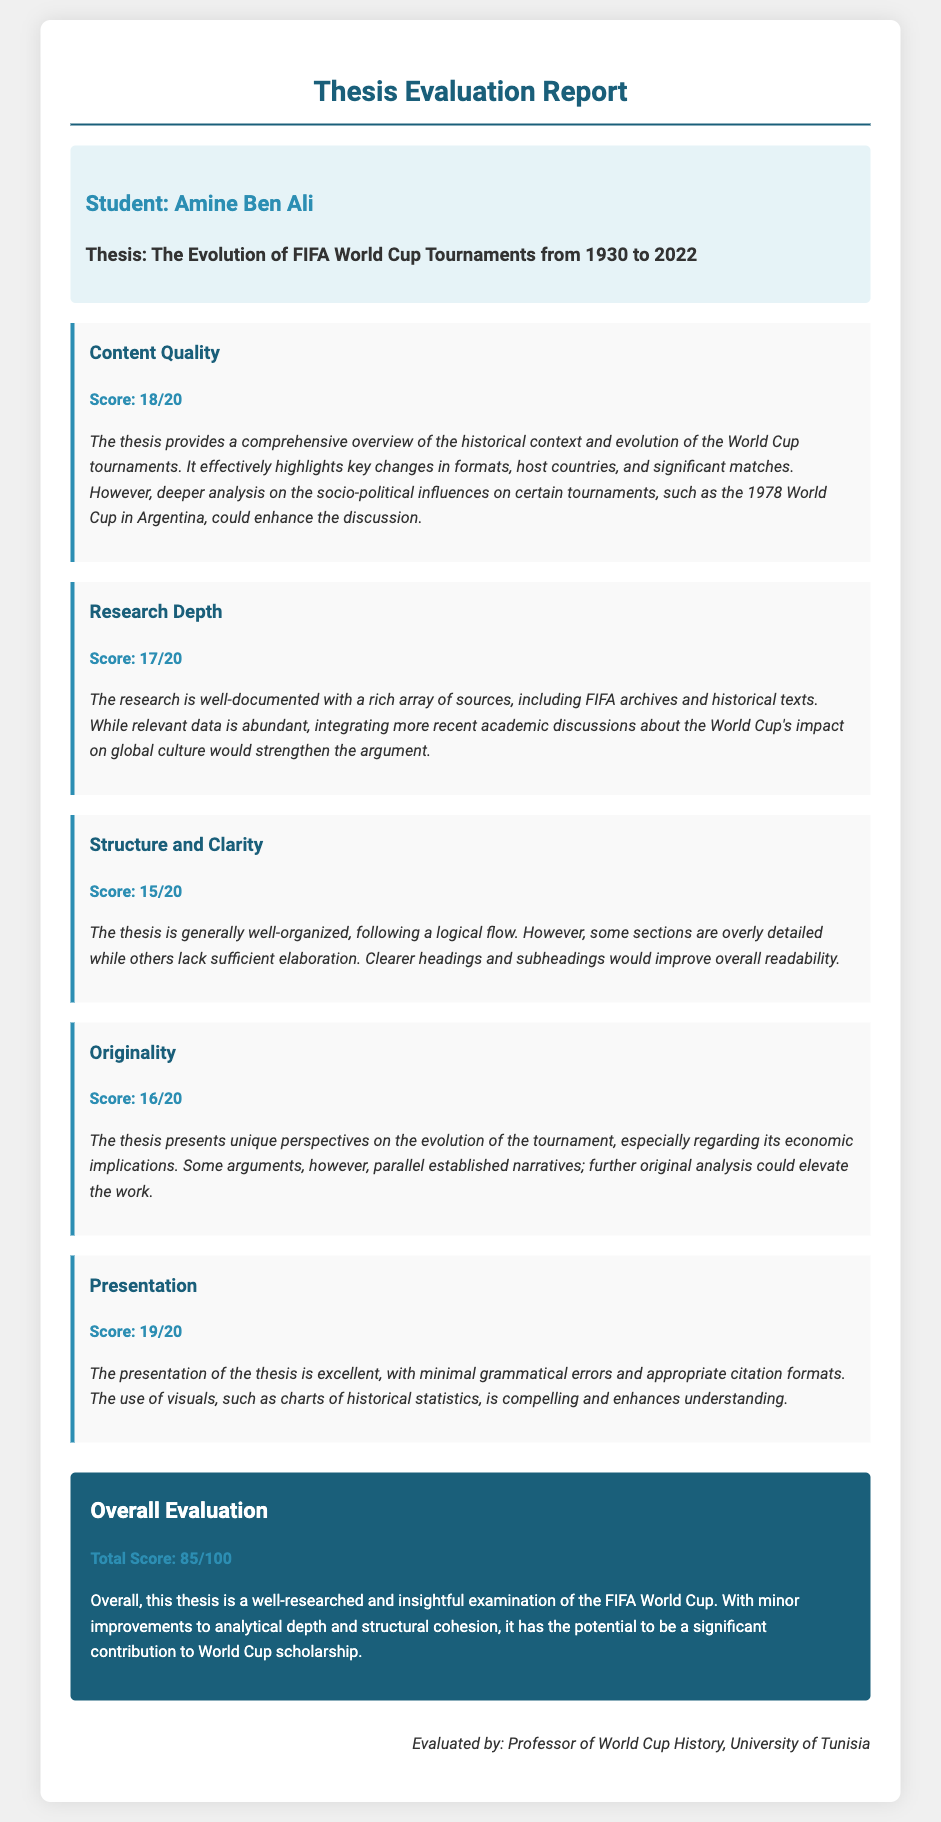What is the name of the student? The student's name is specified in the document under the student info section.
Answer: Amine Ben Ali What is the title of the thesis? The title of the thesis can be found in the same section where the student's name is listed.
Answer: The Evolution of FIFA World Cup Tournaments from 1930 to 2022 What is the score for Content Quality? The score for Content Quality is provided in the criteria section of the evaluation report.
Answer: 18/20 What feedback is given for Research Depth? The feedback for Research Depth summarizes the strengths and suggested improvements for that criteria.
Answer: The research is well-documented with a rich array of sources, including FIFA archives and historical texts. While relevant data is abundant, integrating more recent academic discussions about the World Cup's impact on global culture would strengthen the argument What is the total score of the thesis? The total score is calculated and displayed in the Overall Evaluation section.
Answer: 85/100 Which aspect received the highest score? By comparing the scores in each criteria section, we can determine which area was rated the highest.
Answer: Presentation What suggestion is given to improve Structure and Clarity? The feedback for Structure and Clarity discusses the organization of the thesis and offers a specific suggestion for improvement.
Answer: Clearer headings and subheadings would improve overall readability Who evaluated the thesis? The evaluator's name and title are mentioned in the signature section at the end of the document.
Answer: Professor of World Cup History, University of Tunisia What year range does the thesis cover? The year range is indicated in the title of the thesis.
Answer: 1930 to 2022 